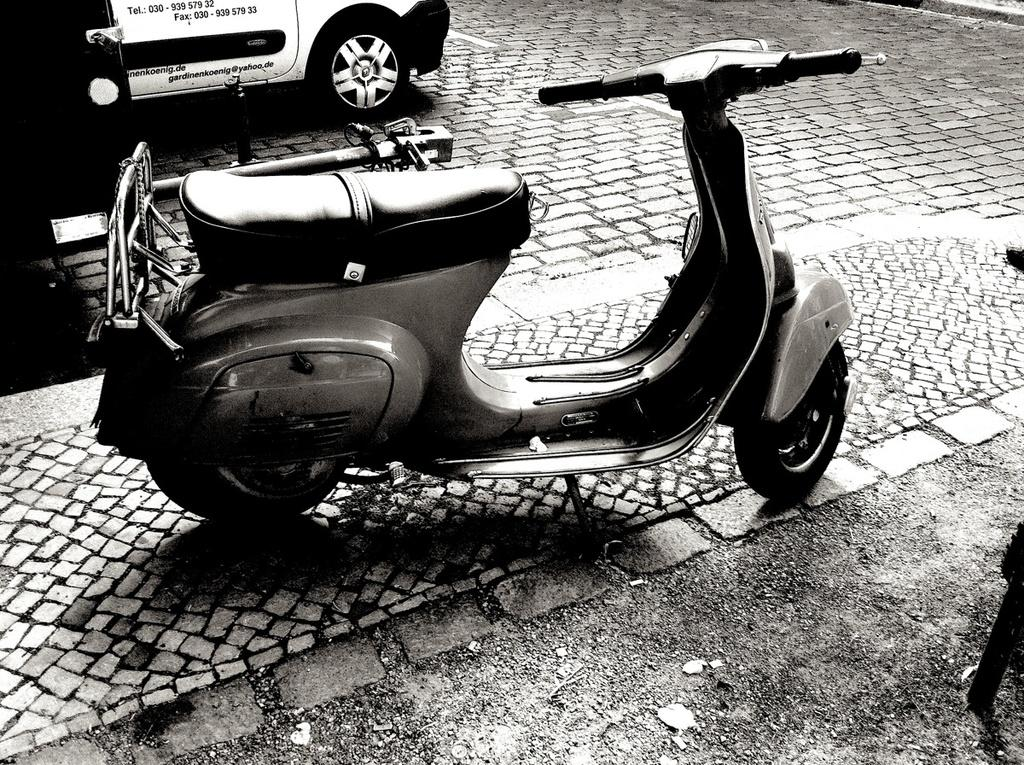What is the color scheme of the image? The image is black and white. What type of vehicle can be seen in the image? There is a scooter and a car in the image. Where are the scooter and car located in the image? Both the scooter and car are on a pavement. What is the name of the person who is surprised by the scooter and car in the image? There is no person present in the image, and therefore no one can be surprised by the scooter and car. 